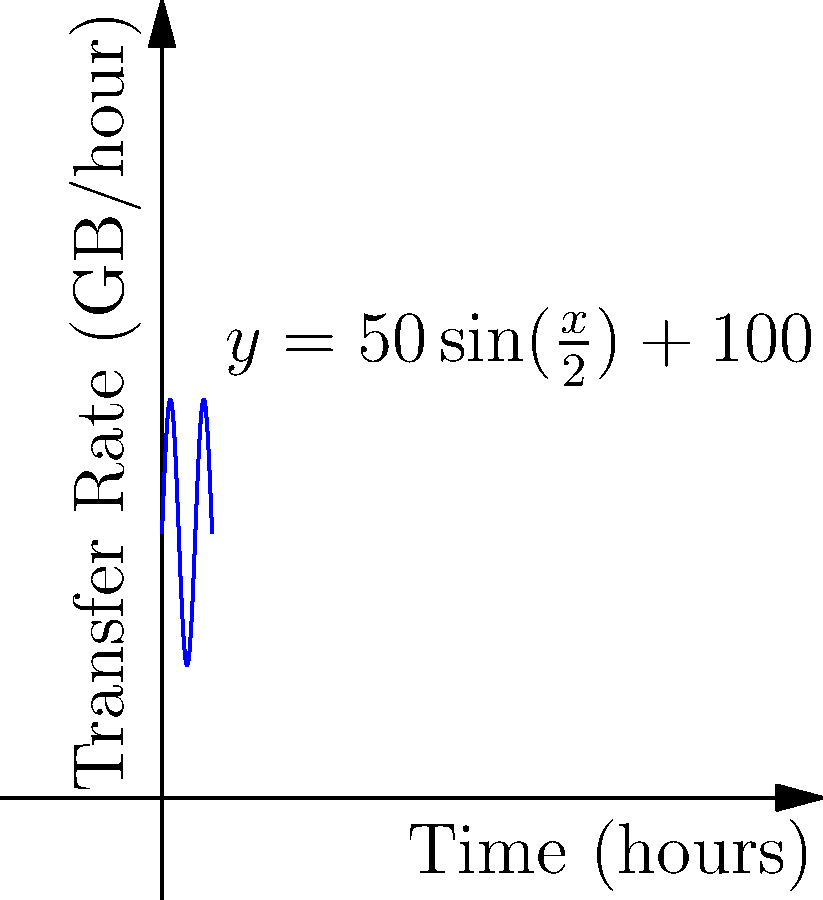During a backup process, the data transfer rate (in GB/hour) varies according to the function $y = 50\sin(\frac{x}{2}) + 100$, where $x$ is the time in hours. Calculate the total amount of data transferred over a 12-hour period. To find the total amount of data transferred, we need to calculate the area under the curve over the 12-hour period. This can be done using a definite integral.

1. Set up the integral:
   $$\int_0^{12} (50\sin(\frac{x}{2}) + 100) dx$$

2. Integrate the function:
   $$\left[-100\cos(\frac{x}{2}) + 100x\right]_0^{12}$$

3. Evaluate the integral:
   $$[-100\cos(6) + 1200] - [-100\cos(0) + 0]$$
   $$= [-100(-0.96) + 1200] - [-100(1) + 0]$$
   $$= 96 + 1200 - (-100)$$
   $$= 1396$$

Therefore, the total amount of data transferred over the 12-hour period is 1396 GB.
Answer: 1396 GB 